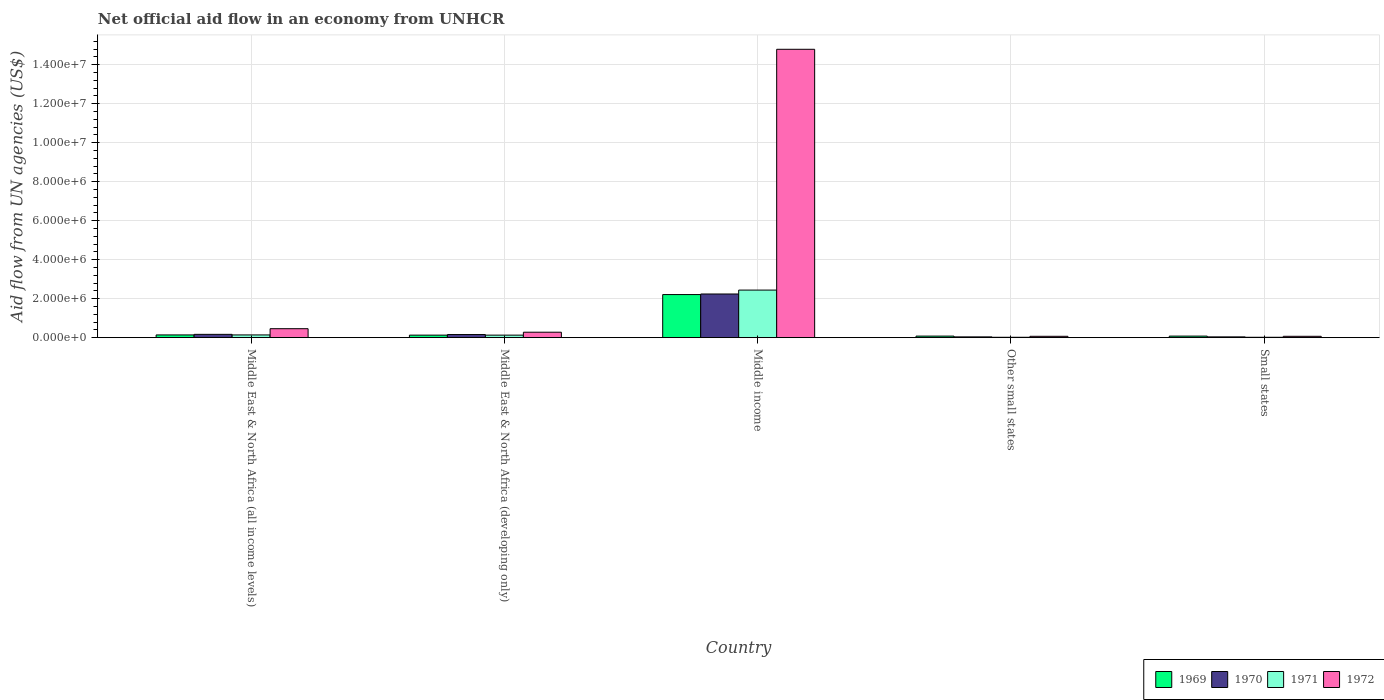How many different coloured bars are there?
Your response must be concise. 4. How many groups of bars are there?
Keep it short and to the point. 5. Are the number of bars on each tick of the X-axis equal?
Offer a very short reply. Yes. How many bars are there on the 3rd tick from the left?
Ensure brevity in your answer.  4. How many bars are there on the 4th tick from the right?
Give a very brief answer. 4. What is the label of the 4th group of bars from the left?
Offer a terse response. Other small states. Across all countries, what is the maximum net official aid flow in 1969?
Ensure brevity in your answer.  2.21e+06. In which country was the net official aid flow in 1971 minimum?
Give a very brief answer. Other small states. What is the total net official aid flow in 1971 in the graph?
Your answer should be very brief. 2.75e+06. What is the difference between the net official aid flow in 1970 in Middle East & North Africa (all income levels) and that in Middle income?
Ensure brevity in your answer.  -2.07e+06. What is the average net official aid flow in 1972 per country?
Give a very brief answer. 3.13e+06. What is the ratio of the net official aid flow in 1972 in Middle East & North Africa (developing only) to that in Other small states?
Ensure brevity in your answer.  4. What is the difference between the highest and the second highest net official aid flow in 1971?
Give a very brief answer. 2.30e+06. What is the difference between the highest and the lowest net official aid flow in 1970?
Your answer should be very brief. 2.20e+06. In how many countries, is the net official aid flow in 1970 greater than the average net official aid flow in 1970 taken over all countries?
Provide a succinct answer. 1. Is the sum of the net official aid flow in 1971 in Middle income and Small states greater than the maximum net official aid flow in 1972 across all countries?
Make the answer very short. No. What does the 3rd bar from the left in Middle East & North Africa (developing only) represents?
Ensure brevity in your answer.  1971. What does the 3rd bar from the right in Middle income represents?
Provide a succinct answer. 1970. Does the graph contain any zero values?
Provide a succinct answer. No. Where does the legend appear in the graph?
Give a very brief answer. Bottom right. What is the title of the graph?
Give a very brief answer. Net official aid flow in an economy from UNHCR. Does "2009" appear as one of the legend labels in the graph?
Your response must be concise. No. What is the label or title of the Y-axis?
Your answer should be very brief. Aid flow from UN agencies (US$). What is the Aid flow from UN agencies (US$) of 1970 in Middle East & North Africa (all income levels)?
Offer a terse response. 1.70e+05. What is the Aid flow from UN agencies (US$) in 1972 in Middle East & North Africa (all income levels)?
Offer a terse response. 4.60e+05. What is the Aid flow from UN agencies (US$) of 1969 in Middle East & North Africa (developing only)?
Make the answer very short. 1.30e+05. What is the Aid flow from UN agencies (US$) of 1972 in Middle East & North Africa (developing only)?
Your answer should be compact. 2.80e+05. What is the Aid flow from UN agencies (US$) of 1969 in Middle income?
Your answer should be compact. 2.21e+06. What is the Aid flow from UN agencies (US$) in 1970 in Middle income?
Your answer should be very brief. 2.24e+06. What is the Aid flow from UN agencies (US$) in 1971 in Middle income?
Ensure brevity in your answer.  2.44e+06. What is the Aid flow from UN agencies (US$) in 1972 in Middle income?
Offer a very short reply. 1.48e+07. What is the Aid flow from UN agencies (US$) of 1969 in Other small states?
Provide a succinct answer. 8.00e+04. What is the Aid flow from UN agencies (US$) of 1970 in Other small states?
Offer a terse response. 4.00e+04. What is the Aid flow from UN agencies (US$) in 1972 in Other small states?
Your answer should be very brief. 7.00e+04. What is the Aid flow from UN agencies (US$) of 1971 in Small states?
Ensure brevity in your answer.  2.00e+04. Across all countries, what is the maximum Aid flow from UN agencies (US$) of 1969?
Provide a succinct answer. 2.21e+06. Across all countries, what is the maximum Aid flow from UN agencies (US$) in 1970?
Provide a short and direct response. 2.24e+06. Across all countries, what is the maximum Aid flow from UN agencies (US$) of 1971?
Keep it short and to the point. 2.44e+06. Across all countries, what is the maximum Aid flow from UN agencies (US$) in 1972?
Ensure brevity in your answer.  1.48e+07. Across all countries, what is the minimum Aid flow from UN agencies (US$) of 1969?
Make the answer very short. 8.00e+04. Across all countries, what is the minimum Aid flow from UN agencies (US$) in 1970?
Provide a short and direct response. 4.00e+04. Across all countries, what is the minimum Aid flow from UN agencies (US$) of 1971?
Make the answer very short. 2.00e+04. What is the total Aid flow from UN agencies (US$) in 1969 in the graph?
Offer a very short reply. 2.64e+06. What is the total Aid flow from UN agencies (US$) of 1970 in the graph?
Offer a terse response. 2.65e+06. What is the total Aid flow from UN agencies (US$) of 1971 in the graph?
Your response must be concise. 2.75e+06. What is the total Aid flow from UN agencies (US$) in 1972 in the graph?
Your response must be concise. 1.57e+07. What is the difference between the Aid flow from UN agencies (US$) of 1971 in Middle East & North Africa (all income levels) and that in Middle East & North Africa (developing only)?
Make the answer very short. 10000. What is the difference between the Aid flow from UN agencies (US$) in 1969 in Middle East & North Africa (all income levels) and that in Middle income?
Offer a terse response. -2.07e+06. What is the difference between the Aid flow from UN agencies (US$) of 1970 in Middle East & North Africa (all income levels) and that in Middle income?
Provide a succinct answer. -2.07e+06. What is the difference between the Aid flow from UN agencies (US$) in 1971 in Middle East & North Africa (all income levels) and that in Middle income?
Ensure brevity in your answer.  -2.30e+06. What is the difference between the Aid flow from UN agencies (US$) of 1972 in Middle East & North Africa (all income levels) and that in Middle income?
Make the answer very short. -1.43e+07. What is the difference between the Aid flow from UN agencies (US$) in 1969 in Middle East & North Africa (all income levels) and that in Other small states?
Ensure brevity in your answer.  6.00e+04. What is the difference between the Aid flow from UN agencies (US$) in 1971 in Middle East & North Africa (all income levels) and that in Other small states?
Offer a terse response. 1.20e+05. What is the difference between the Aid flow from UN agencies (US$) in 1972 in Middle East & North Africa (all income levels) and that in Other small states?
Your response must be concise. 3.90e+05. What is the difference between the Aid flow from UN agencies (US$) in 1969 in Middle East & North Africa (all income levels) and that in Small states?
Provide a short and direct response. 6.00e+04. What is the difference between the Aid flow from UN agencies (US$) of 1969 in Middle East & North Africa (developing only) and that in Middle income?
Keep it short and to the point. -2.08e+06. What is the difference between the Aid flow from UN agencies (US$) in 1970 in Middle East & North Africa (developing only) and that in Middle income?
Ensure brevity in your answer.  -2.08e+06. What is the difference between the Aid flow from UN agencies (US$) in 1971 in Middle East & North Africa (developing only) and that in Middle income?
Your response must be concise. -2.31e+06. What is the difference between the Aid flow from UN agencies (US$) in 1972 in Middle East & North Africa (developing only) and that in Middle income?
Give a very brief answer. -1.45e+07. What is the difference between the Aid flow from UN agencies (US$) in 1972 in Middle East & North Africa (developing only) and that in Other small states?
Ensure brevity in your answer.  2.10e+05. What is the difference between the Aid flow from UN agencies (US$) in 1971 in Middle East & North Africa (developing only) and that in Small states?
Offer a terse response. 1.10e+05. What is the difference between the Aid flow from UN agencies (US$) in 1972 in Middle East & North Africa (developing only) and that in Small states?
Provide a succinct answer. 2.10e+05. What is the difference between the Aid flow from UN agencies (US$) of 1969 in Middle income and that in Other small states?
Make the answer very short. 2.13e+06. What is the difference between the Aid flow from UN agencies (US$) of 1970 in Middle income and that in Other small states?
Offer a terse response. 2.20e+06. What is the difference between the Aid flow from UN agencies (US$) in 1971 in Middle income and that in Other small states?
Your answer should be very brief. 2.42e+06. What is the difference between the Aid flow from UN agencies (US$) of 1972 in Middle income and that in Other small states?
Offer a very short reply. 1.47e+07. What is the difference between the Aid flow from UN agencies (US$) in 1969 in Middle income and that in Small states?
Offer a very short reply. 2.13e+06. What is the difference between the Aid flow from UN agencies (US$) in 1970 in Middle income and that in Small states?
Provide a succinct answer. 2.20e+06. What is the difference between the Aid flow from UN agencies (US$) in 1971 in Middle income and that in Small states?
Offer a terse response. 2.42e+06. What is the difference between the Aid flow from UN agencies (US$) in 1972 in Middle income and that in Small states?
Offer a very short reply. 1.47e+07. What is the difference between the Aid flow from UN agencies (US$) of 1969 in Other small states and that in Small states?
Your response must be concise. 0. What is the difference between the Aid flow from UN agencies (US$) of 1970 in Other small states and that in Small states?
Your answer should be compact. 0. What is the difference between the Aid flow from UN agencies (US$) of 1971 in Other small states and that in Small states?
Keep it short and to the point. 0. What is the difference between the Aid flow from UN agencies (US$) of 1972 in Other small states and that in Small states?
Provide a succinct answer. 0. What is the difference between the Aid flow from UN agencies (US$) of 1969 in Middle East & North Africa (all income levels) and the Aid flow from UN agencies (US$) of 1970 in Middle East & North Africa (developing only)?
Your response must be concise. -2.00e+04. What is the difference between the Aid flow from UN agencies (US$) in 1971 in Middle East & North Africa (all income levels) and the Aid flow from UN agencies (US$) in 1972 in Middle East & North Africa (developing only)?
Your answer should be very brief. -1.40e+05. What is the difference between the Aid flow from UN agencies (US$) of 1969 in Middle East & North Africa (all income levels) and the Aid flow from UN agencies (US$) of 1970 in Middle income?
Your response must be concise. -2.10e+06. What is the difference between the Aid flow from UN agencies (US$) in 1969 in Middle East & North Africa (all income levels) and the Aid flow from UN agencies (US$) in 1971 in Middle income?
Ensure brevity in your answer.  -2.30e+06. What is the difference between the Aid flow from UN agencies (US$) of 1969 in Middle East & North Africa (all income levels) and the Aid flow from UN agencies (US$) of 1972 in Middle income?
Keep it short and to the point. -1.46e+07. What is the difference between the Aid flow from UN agencies (US$) in 1970 in Middle East & North Africa (all income levels) and the Aid flow from UN agencies (US$) in 1971 in Middle income?
Offer a terse response. -2.27e+06. What is the difference between the Aid flow from UN agencies (US$) in 1970 in Middle East & North Africa (all income levels) and the Aid flow from UN agencies (US$) in 1972 in Middle income?
Make the answer very short. -1.46e+07. What is the difference between the Aid flow from UN agencies (US$) of 1971 in Middle East & North Africa (all income levels) and the Aid flow from UN agencies (US$) of 1972 in Middle income?
Your response must be concise. -1.46e+07. What is the difference between the Aid flow from UN agencies (US$) of 1969 in Middle East & North Africa (all income levels) and the Aid flow from UN agencies (US$) of 1971 in Other small states?
Keep it short and to the point. 1.20e+05. What is the difference between the Aid flow from UN agencies (US$) of 1970 in Middle East & North Africa (all income levels) and the Aid flow from UN agencies (US$) of 1971 in Other small states?
Your answer should be compact. 1.50e+05. What is the difference between the Aid flow from UN agencies (US$) of 1970 in Middle East & North Africa (all income levels) and the Aid flow from UN agencies (US$) of 1972 in Other small states?
Provide a short and direct response. 1.00e+05. What is the difference between the Aid flow from UN agencies (US$) in 1971 in Middle East & North Africa (all income levels) and the Aid flow from UN agencies (US$) in 1972 in Other small states?
Your answer should be very brief. 7.00e+04. What is the difference between the Aid flow from UN agencies (US$) in 1970 in Middle East & North Africa (all income levels) and the Aid flow from UN agencies (US$) in 1971 in Small states?
Offer a very short reply. 1.50e+05. What is the difference between the Aid flow from UN agencies (US$) of 1970 in Middle East & North Africa (all income levels) and the Aid flow from UN agencies (US$) of 1972 in Small states?
Your response must be concise. 1.00e+05. What is the difference between the Aid flow from UN agencies (US$) in 1971 in Middle East & North Africa (all income levels) and the Aid flow from UN agencies (US$) in 1972 in Small states?
Offer a very short reply. 7.00e+04. What is the difference between the Aid flow from UN agencies (US$) of 1969 in Middle East & North Africa (developing only) and the Aid flow from UN agencies (US$) of 1970 in Middle income?
Your response must be concise. -2.11e+06. What is the difference between the Aid flow from UN agencies (US$) in 1969 in Middle East & North Africa (developing only) and the Aid flow from UN agencies (US$) in 1971 in Middle income?
Your answer should be compact. -2.31e+06. What is the difference between the Aid flow from UN agencies (US$) of 1969 in Middle East & North Africa (developing only) and the Aid flow from UN agencies (US$) of 1972 in Middle income?
Your answer should be compact. -1.47e+07. What is the difference between the Aid flow from UN agencies (US$) in 1970 in Middle East & North Africa (developing only) and the Aid flow from UN agencies (US$) in 1971 in Middle income?
Provide a short and direct response. -2.28e+06. What is the difference between the Aid flow from UN agencies (US$) of 1970 in Middle East & North Africa (developing only) and the Aid flow from UN agencies (US$) of 1972 in Middle income?
Offer a terse response. -1.46e+07. What is the difference between the Aid flow from UN agencies (US$) in 1971 in Middle East & North Africa (developing only) and the Aid flow from UN agencies (US$) in 1972 in Middle income?
Offer a terse response. -1.47e+07. What is the difference between the Aid flow from UN agencies (US$) of 1969 in Middle East & North Africa (developing only) and the Aid flow from UN agencies (US$) of 1971 in Other small states?
Ensure brevity in your answer.  1.10e+05. What is the difference between the Aid flow from UN agencies (US$) in 1970 in Middle East & North Africa (developing only) and the Aid flow from UN agencies (US$) in 1972 in Other small states?
Keep it short and to the point. 9.00e+04. What is the difference between the Aid flow from UN agencies (US$) of 1969 in Middle East & North Africa (developing only) and the Aid flow from UN agencies (US$) of 1970 in Small states?
Provide a short and direct response. 9.00e+04. What is the difference between the Aid flow from UN agencies (US$) in 1969 in Middle East & North Africa (developing only) and the Aid flow from UN agencies (US$) in 1971 in Small states?
Your answer should be very brief. 1.10e+05. What is the difference between the Aid flow from UN agencies (US$) in 1970 in Middle East & North Africa (developing only) and the Aid flow from UN agencies (US$) in 1972 in Small states?
Provide a short and direct response. 9.00e+04. What is the difference between the Aid flow from UN agencies (US$) in 1969 in Middle income and the Aid flow from UN agencies (US$) in 1970 in Other small states?
Make the answer very short. 2.17e+06. What is the difference between the Aid flow from UN agencies (US$) of 1969 in Middle income and the Aid flow from UN agencies (US$) of 1971 in Other small states?
Give a very brief answer. 2.19e+06. What is the difference between the Aid flow from UN agencies (US$) in 1969 in Middle income and the Aid flow from UN agencies (US$) in 1972 in Other small states?
Ensure brevity in your answer.  2.14e+06. What is the difference between the Aid flow from UN agencies (US$) of 1970 in Middle income and the Aid flow from UN agencies (US$) of 1971 in Other small states?
Your response must be concise. 2.22e+06. What is the difference between the Aid flow from UN agencies (US$) in 1970 in Middle income and the Aid flow from UN agencies (US$) in 1972 in Other small states?
Give a very brief answer. 2.17e+06. What is the difference between the Aid flow from UN agencies (US$) of 1971 in Middle income and the Aid flow from UN agencies (US$) of 1972 in Other small states?
Your answer should be very brief. 2.37e+06. What is the difference between the Aid flow from UN agencies (US$) of 1969 in Middle income and the Aid flow from UN agencies (US$) of 1970 in Small states?
Make the answer very short. 2.17e+06. What is the difference between the Aid flow from UN agencies (US$) in 1969 in Middle income and the Aid flow from UN agencies (US$) in 1971 in Small states?
Offer a terse response. 2.19e+06. What is the difference between the Aid flow from UN agencies (US$) in 1969 in Middle income and the Aid flow from UN agencies (US$) in 1972 in Small states?
Make the answer very short. 2.14e+06. What is the difference between the Aid flow from UN agencies (US$) in 1970 in Middle income and the Aid flow from UN agencies (US$) in 1971 in Small states?
Offer a very short reply. 2.22e+06. What is the difference between the Aid flow from UN agencies (US$) of 1970 in Middle income and the Aid flow from UN agencies (US$) of 1972 in Small states?
Make the answer very short. 2.17e+06. What is the difference between the Aid flow from UN agencies (US$) in 1971 in Middle income and the Aid flow from UN agencies (US$) in 1972 in Small states?
Offer a very short reply. 2.37e+06. What is the difference between the Aid flow from UN agencies (US$) in 1969 in Other small states and the Aid flow from UN agencies (US$) in 1970 in Small states?
Provide a succinct answer. 4.00e+04. What is the difference between the Aid flow from UN agencies (US$) in 1971 in Other small states and the Aid flow from UN agencies (US$) in 1972 in Small states?
Your answer should be very brief. -5.00e+04. What is the average Aid flow from UN agencies (US$) of 1969 per country?
Your answer should be compact. 5.28e+05. What is the average Aid flow from UN agencies (US$) of 1970 per country?
Your answer should be compact. 5.30e+05. What is the average Aid flow from UN agencies (US$) of 1971 per country?
Your response must be concise. 5.50e+05. What is the average Aid flow from UN agencies (US$) in 1972 per country?
Your response must be concise. 3.13e+06. What is the difference between the Aid flow from UN agencies (US$) in 1969 and Aid flow from UN agencies (US$) in 1970 in Middle East & North Africa (all income levels)?
Give a very brief answer. -3.00e+04. What is the difference between the Aid flow from UN agencies (US$) of 1969 and Aid flow from UN agencies (US$) of 1972 in Middle East & North Africa (all income levels)?
Your answer should be compact. -3.20e+05. What is the difference between the Aid flow from UN agencies (US$) in 1970 and Aid flow from UN agencies (US$) in 1972 in Middle East & North Africa (all income levels)?
Provide a succinct answer. -2.90e+05. What is the difference between the Aid flow from UN agencies (US$) in 1971 and Aid flow from UN agencies (US$) in 1972 in Middle East & North Africa (all income levels)?
Offer a very short reply. -3.20e+05. What is the difference between the Aid flow from UN agencies (US$) of 1969 and Aid flow from UN agencies (US$) of 1971 in Middle East & North Africa (developing only)?
Offer a terse response. 0. What is the difference between the Aid flow from UN agencies (US$) in 1969 and Aid flow from UN agencies (US$) in 1972 in Middle East & North Africa (developing only)?
Provide a succinct answer. -1.50e+05. What is the difference between the Aid flow from UN agencies (US$) of 1970 and Aid flow from UN agencies (US$) of 1972 in Middle East & North Africa (developing only)?
Provide a short and direct response. -1.20e+05. What is the difference between the Aid flow from UN agencies (US$) in 1969 and Aid flow from UN agencies (US$) in 1971 in Middle income?
Provide a succinct answer. -2.30e+05. What is the difference between the Aid flow from UN agencies (US$) of 1969 and Aid flow from UN agencies (US$) of 1972 in Middle income?
Provide a short and direct response. -1.26e+07. What is the difference between the Aid flow from UN agencies (US$) of 1970 and Aid flow from UN agencies (US$) of 1972 in Middle income?
Make the answer very short. -1.26e+07. What is the difference between the Aid flow from UN agencies (US$) in 1971 and Aid flow from UN agencies (US$) in 1972 in Middle income?
Provide a short and direct response. -1.24e+07. What is the difference between the Aid flow from UN agencies (US$) of 1969 and Aid flow from UN agencies (US$) of 1971 in Other small states?
Your response must be concise. 6.00e+04. What is the difference between the Aid flow from UN agencies (US$) in 1970 and Aid flow from UN agencies (US$) in 1971 in Other small states?
Provide a succinct answer. 2.00e+04. What is the difference between the Aid flow from UN agencies (US$) in 1971 and Aid flow from UN agencies (US$) in 1972 in Other small states?
Your response must be concise. -5.00e+04. What is the difference between the Aid flow from UN agencies (US$) of 1969 and Aid flow from UN agencies (US$) of 1972 in Small states?
Offer a very short reply. 10000. What is the difference between the Aid flow from UN agencies (US$) of 1970 and Aid flow from UN agencies (US$) of 1971 in Small states?
Ensure brevity in your answer.  2.00e+04. What is the difference between the Aid flow from UN agencies (US$) in 1971 and Aid flow from UN agencies (US$) in 1972 in Small states?
Offer a terse response. -5.00e+04. What is the ratio of the Aid flow from UN agencies (US$) in 1970 in Middle East & North Africa (all income levels) to that in Middle East & North Africa (developing only)?
Your answer should be compact. 1.06. What is the ratio of the Aid flow from UN agencies (US$) in 1972 in Middle East & North Africa (all income levels) to that in Middle East & North Africa (developing only)?
Your answer should be compact. 1.64. What is the ratio of the Aid flow from UN agencies (US$) in 1969 in Middle East & North Africa (all income levels) to that in Middle income?
Provide a short and direct response. 0.06. What is the ratio of the Aid flow from UN agencies (US$) in 1970 in Middle East & North Africa (all income levels) to that in Middle income?
Ensure brevity in your answer.  0.08. What is the ratio of the Aid flow from UN agencies (US$) of 1971 in Middle East & North Africa (all income levels) to that in Middle income?
Keep it short and to the point. 0.06. What is the ratio of the Aid flow from UN agencies (US$) of 1972 in Middle East & North Africa (all income levels) to that in Middle income?
Offer a very short reply. 0.03. What is the ratio of the Aid flow from UN agencies (US$) of 1970 in Middle East & North Africa (all income levels) to that in Other small states?
Give a very brief answer. 4.25. What is the ratio of the Aid flow from UN agencies (US$) in 1971 in Middle East & North Africa (all income levels) to that in Other small states?
Make the answer very short. 7. What is the ratio of the Aid flow from UN agencies (US$) in 1972 in Middle East & North Africa (all income levels) to that in Other small states?
Ensure brevity in your answer.  6.57. What is the ratio of the Aid flow from UN agencies (US$) of 1970 in Middle East & North Africa (all income levels) to that in Small states?
Ensure brevity in your answer.  4.25. What is the ratio of the Aid flow from UN agencies (US$) in 1971 in Middle East & North Africa (all income levels) to that in Small states?
Offer a very short reply. 7. What is the ratio of the Aid flow from UN agencies (US$) of 1972 in Middle East & North Africa (all income levels) to that in Small states?
Your answer should be very brief. 6.57. What is the ratio of the Aid flow from UN agencies (US$) of 1969 in Middle East & North Africa (developing only) to that in Middle income?
Provide a short and direct response. 0.06. What is the ratio of the Aid flow from UN agencies (US$) in 1970 in Middle East & North Africa (developing only) to that in Middle income?
Offer a very short reply. 0.07. What is the ratio of the Aid flow from UN agencies (US$) of 1971 in Middle East & North Africa (developing only) to that in Middle income?
Make the answer very short. 0.05. What is the ratio of the Aid flow from UN agencies (US$) in 1972 in Middle East & North Africa (developing only) to that in Middle income?
Make the answer very short. 0.02. What is the ratio of the Aid flow from UN agencies (US$) in 1969 in Middle East & North Africa (developing only) to that in Other small states?
Provide a succinct answer. 1.62. What is the ratio of the Aid flow from UN agencies (US$) of 1971 in Middle East & North Africa (developing only) to that in Other small states?
Your answer should be compact. 6.5. What is the ratio of the Aid flow from UN agencies (US$) of 1969 in Middle East & North Africa (developing only) to that in Small states?
Provide a short and direct response. 1.62. What is the ratio of the Aid flow from UN agencies (US$) in 1970 in Middle East & North Africa (developing only) to that in Small states?
Offer a very short reply. 4. What is the ratio of the Aid flow from UN agencies (US$) in 1972 in Middle East & North Africa (developing only) to that in Small states?
Give a very brief answer. 4. What is the ratio of the Aid flow from UN agencies (US$) in 1969 in Middle income to that in Other small states?
Your response must be concise. 27.62. What is the ratio of the Aid flow from UN agencies (US$) of 1970 in Middle income to that in Other small states?
Provide a short and direct response. 56. What is the ratio of the Aid flow from UN agencies (US$) of 1971 in Middle income to that in Other small states?
Offer a terse response. 122. What is the ratio of the Aid flow from UN agencies (US$) of 1972 in Middle income to that in Other small states?
Offer a very short reply. 211.29. What is the ratio of the Aid flow from UN agencies (US$) in 1969 in Middle income to that in Small states?
Your response must be concise. 27.62. What is the ratio of the Aid flow from UN agencies (US$) of 1971 in Middle income to that in Small states?
Provide a succinct answer. 122. What is the ratio of the Aid flow from UN agencies (US$) in 1972 in Middle income to that in Small states?
Keep it short and to the point. 211.29. What is the ratio of the Aid flow from UN agencies (US$) in 1969 in Other small states to that in Small states?
Ensure brevity in your answer.  1. What is the ratio of the Aid flow from UN agencies (US$) of 1970 in Other small states to that in Small states?
Your response must be concise. 1. What is the ratio of the Aid flow from UN agencies (US$) in 1971 in Other small states to that in Small states?
Make the answer very short. 1. What is the ratio of the Aid flow from UN agencies (US$) of 1972 in Other small states to that in Small states?
Ensure brevity in your answer.  1. What is the difference between the highest and the second highest Aid flow from UN agencies (US$) in 1969?
Give a very brief answer. 2.07e+06. What is the difference between the highest and the second highest Aid flow from UN agencies (US$) in 1970?
Offer a terse response. 2.07e+06. What is the difference between the highest and the second highest Aid flow from UN agencies (US$) in 1971?
Your response must be concise. 2.30e+06. What is the difference between the highest and the second highest Aid flow from UN agencies (US$) of 1972?
Keep it short and to the point. 1.43e+07. What is the difference between the highest and the lowest Aid flow from UN agencies (US$) in 1969?
Make the answer very short. 2.13e+06. What is the difference between the highest and the lowest Aid flow from UN agencies (US$) of 1970?
Your answer should be very brief. 2.20e+06. What is the difference between the highest and the lowest Aid flow from UN agencies (US$) of 1971?
Provide a short and direct response. 2.42e+06. What is the difference between the highest and the lowest Aid flow from UN agencies (US$) in 1972?
Provide a short and direct response. 1.47e+07. 